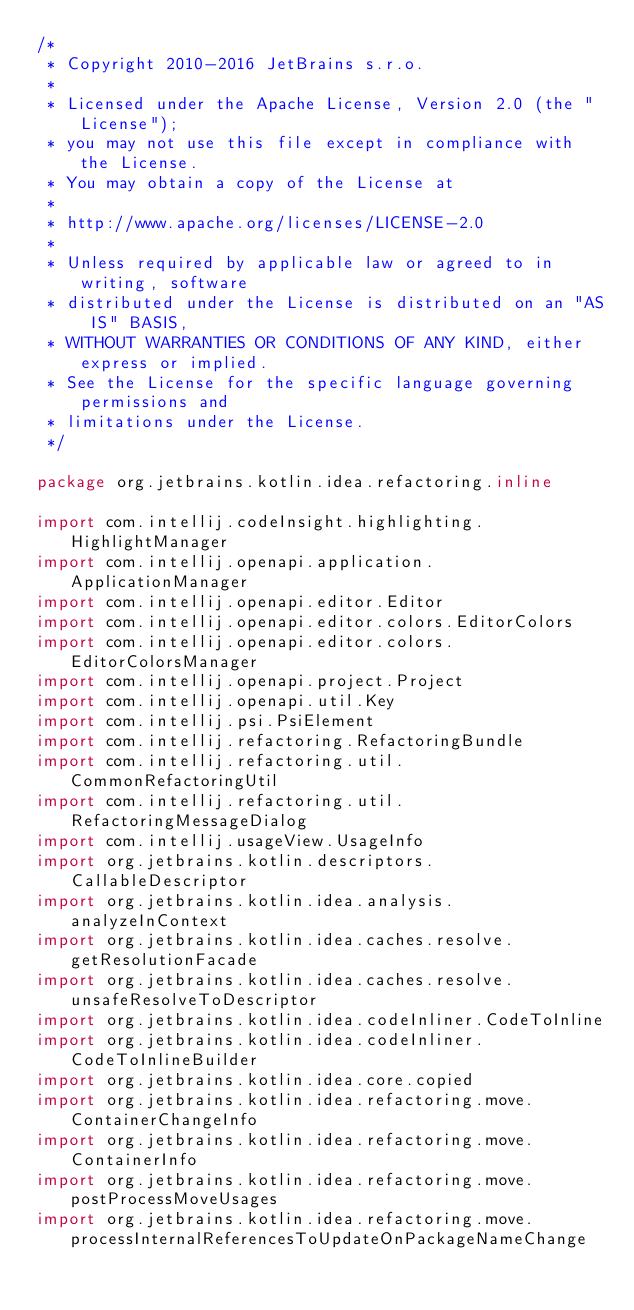Convert code to text. <code><loc_0><loc_0><loc_500><loc_500><_Kotlin_>/*
 * Copyright 2010-2016 JetBrains s.r.o.
 *
 * Licensed under the Apache License, Version 2.0 (the "License");
 * you may not use this file except in compliance with the License.
 * You may obtain a copy of the License at
 *
 * http://www.apache.org/licenses/LICENSE-2.0
 *
 * Unless required by applicable law or agreed to in writing, software
 * distributed under the License is distributed on an "AS IS" BASIS,
 * WITHOUT WARRANTIES OR CONDITIONS OF ANY KIND, either express or implied.
 * See the License for the specific language governing permissions and
 * limitations under the License.
 */

package org.jetbrains.kotlin.idea.refactoring.inline

import com.intellij.codeInsight.highlighting.HighlightManager
import com.intellij.openapi.application.ApplicationManager
import com.intellij.openapi.editor.Editor
import com.intellij.openapi.editor.colors.EditorColors
import com.intellij.openapi.editor.colors.EditorColorsManager
import com.intellij.openapi.project.Project
import com.intellij.openapi.util.Key
import com.intellij.psi.PsiElement
import com.intellij.refactoring.RefactoringBundle
import com.intellij.refactoring.util.CommonRefactoringUtil
import com.intellij.refactoring.util.RefactoringMessageDialog
import com.intellij.usageView.UsageInfo
import org.jetbrains.kotlin.descriptors.CallableDescriptor
import org.jetbrains.kotlin.idea.analysis.analyzeInContext
import org.jetbrains.kotlin.idea.caches.resolve.getResolutionFacade
import org.jetbrains.kotlin.idea.caches.resolve.unsafeResolveToDescriptor
import org.jetbrains.kotlin.idea.codeInliner.CodeToInline
import org.jetbrains.kotlin.idea.codeInliner.CodeToInlineBuilder
import org.jetbrains.kotlin.idea.core.copied
import org.jetbrains.kotlin.idea.refactoring.move.ContainerChangeInfo
import org.jetbrains.kotlin.idea.refactoring.move.ContainerInfo
import org.jetbrains.kotlin.idea.refactoring.move.postProcessMoveUsages
import org.jetbrains.kotlin.idea.refactoring.move.processInternalReferencesToUpdateOnPackageNameChange</code> 